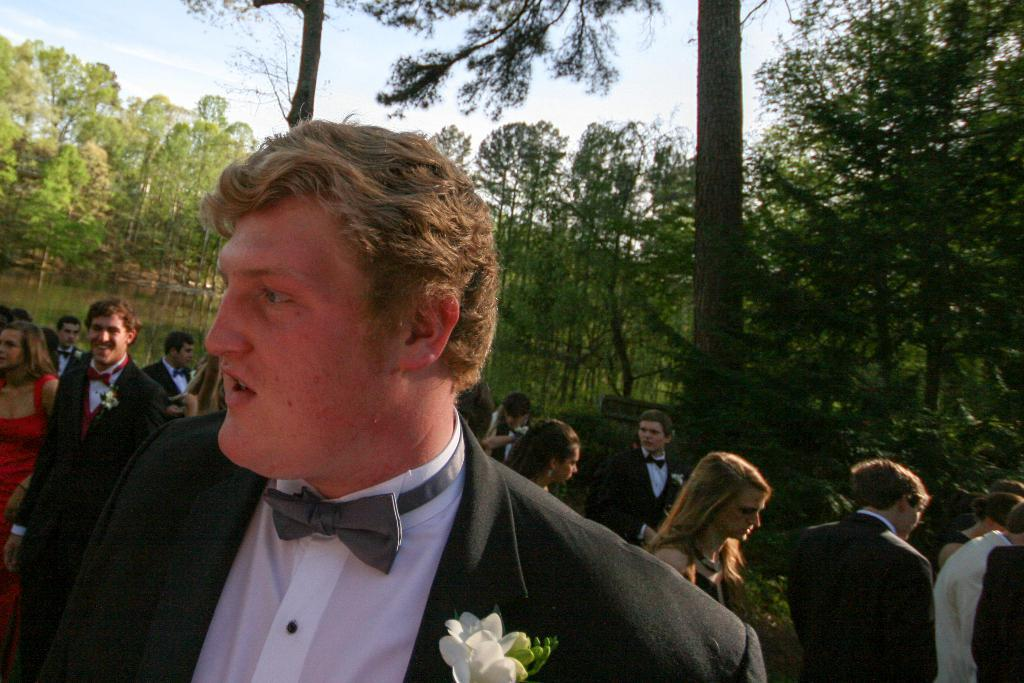What is the main subject of the image? There is a man standing in the image. What is the man wearing? The man is wearing a suit. Can you describe the people in the background of the image? There is a group of people standing at the back in the image. What type of natural environment is visible in the image? There are many trees visible in the image. What is visible at the top of the image? The sky is visible at the top of the image. What type of lace can be seen on the man's suit in the image? There is no lace visible on the man's suit in the image. What type of trade is being conducted by the group of people in the image? There is no indication of any trade being conducted in the image; it simply shows a man and a group of people standing. 